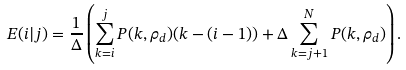Convert formula to latex. <formula><loc_0><loc_0><loc_500><loc_500>E ( i | j ) = \frac { 1 } { \Delta } \left ( \sum _ { k = i } ^ { j } P ( k , \rho _ { d } ) ( k - ( i - 1 ) ) + \Delta \sum _ { k = j + 1 } ^ { N } P ( k , \rho _ { d } ) \right ) .</formula> 